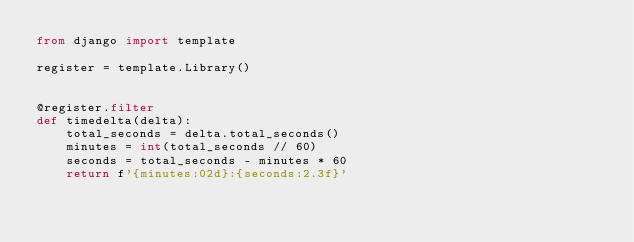<code> <loc_0><loc_0><loc_500><loc_500><_Python_>from django import template

register = template.Library()


@register.filter
def timedelta(delta):
    total_seconds = delta.total_seconds()
    minutes = int(total_seconds // 60)
    seconds = total_seconds - minutes * 60
    return f'{minutes:02d}:{seconds:2.3f}'
</code> 